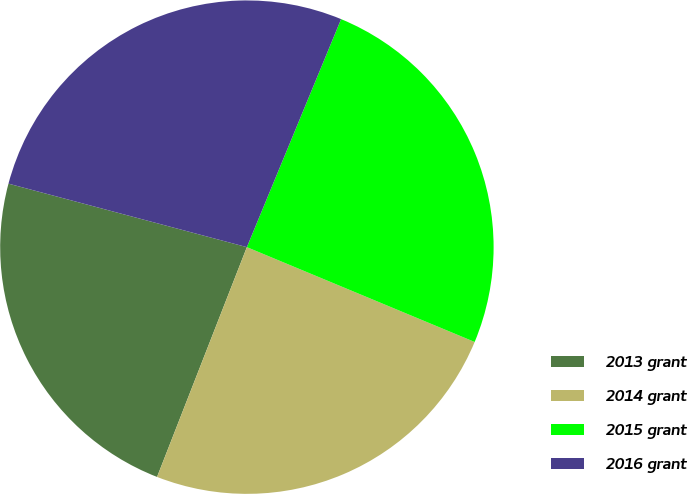Convert chart to OTSL. <chart><loc_0><loc_0><loc_500><loc_500><pie_chart><fcel>2013 grant<fcel>2014 grant<fcel>2015 grant<fcel>2016 grant<nl><fcel>23.21%<fcel>24.65%<fcel>25.04%<fcel>27.09%<nl></chart> 